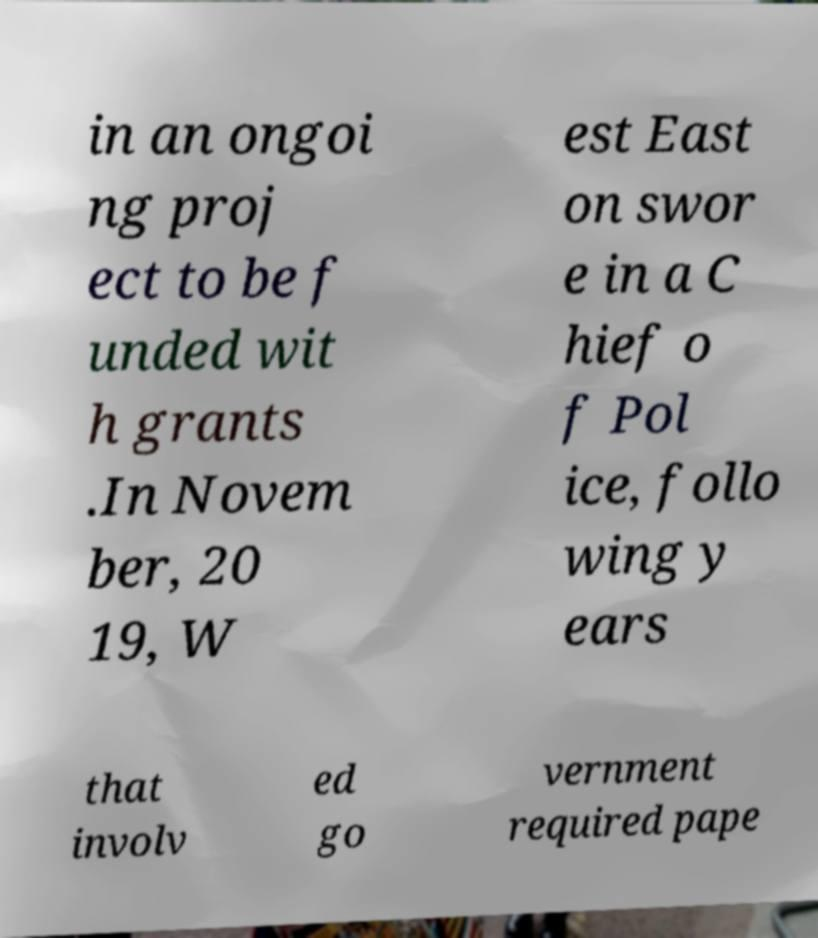Can you accurately transcribe the text from the provided image for me? in an ongoi ng proj ect to be f unded wit h grants .In Novem ber, 20 19, W est East on swor e in a C hief o f Pol ice, follo wing y ears that involv ed go vernment required pape 